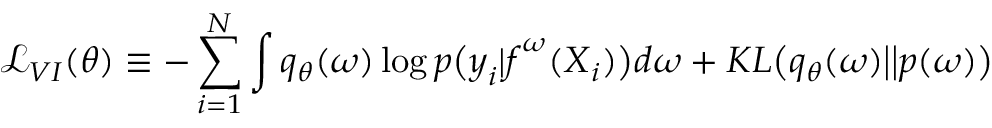<formula> <loc_0><loc_0><loc_500><loc_500>\mathcal { L } _ { V I } ( \theta ) \equiv - \sum _ { i = 1 } ^ { N } \int q _ { \theta } ( \omega ) \log p \left ( y _ { i } | f ^ { \omega } ( X _ { i } ) \right ) d \omega + K L \left ( q _ { \theta } ( \omega ) \left | \right | p ( \omega ) \right )</formula> 